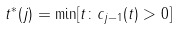Convert formula to latex. <formula><loc_0><loc_0><loc_500><loc_500>t ^ { * } ( j ) = \min [ t \colon c _ { j - 1 } ( t ) > 0 ]</formula> 